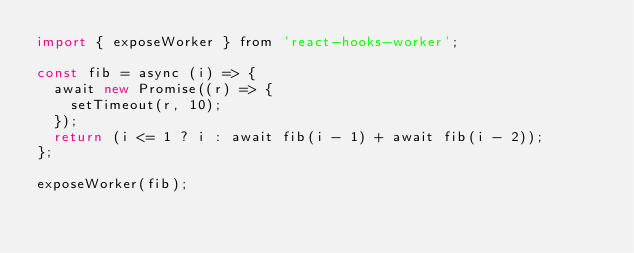<code> <loc_0><loc_0><loc_500><loc_500><_JavaScript_>import { exposeWorker } from 'react-hooks-worker';

const fib = async (i) => {
  await new Promise((r) => {
    setTimeout(r, 10);
  });
  return (i <= 1 ? i : await fib(i - 1) + await fib(i - 2));
};

exposeWorker(fib);
</code> 